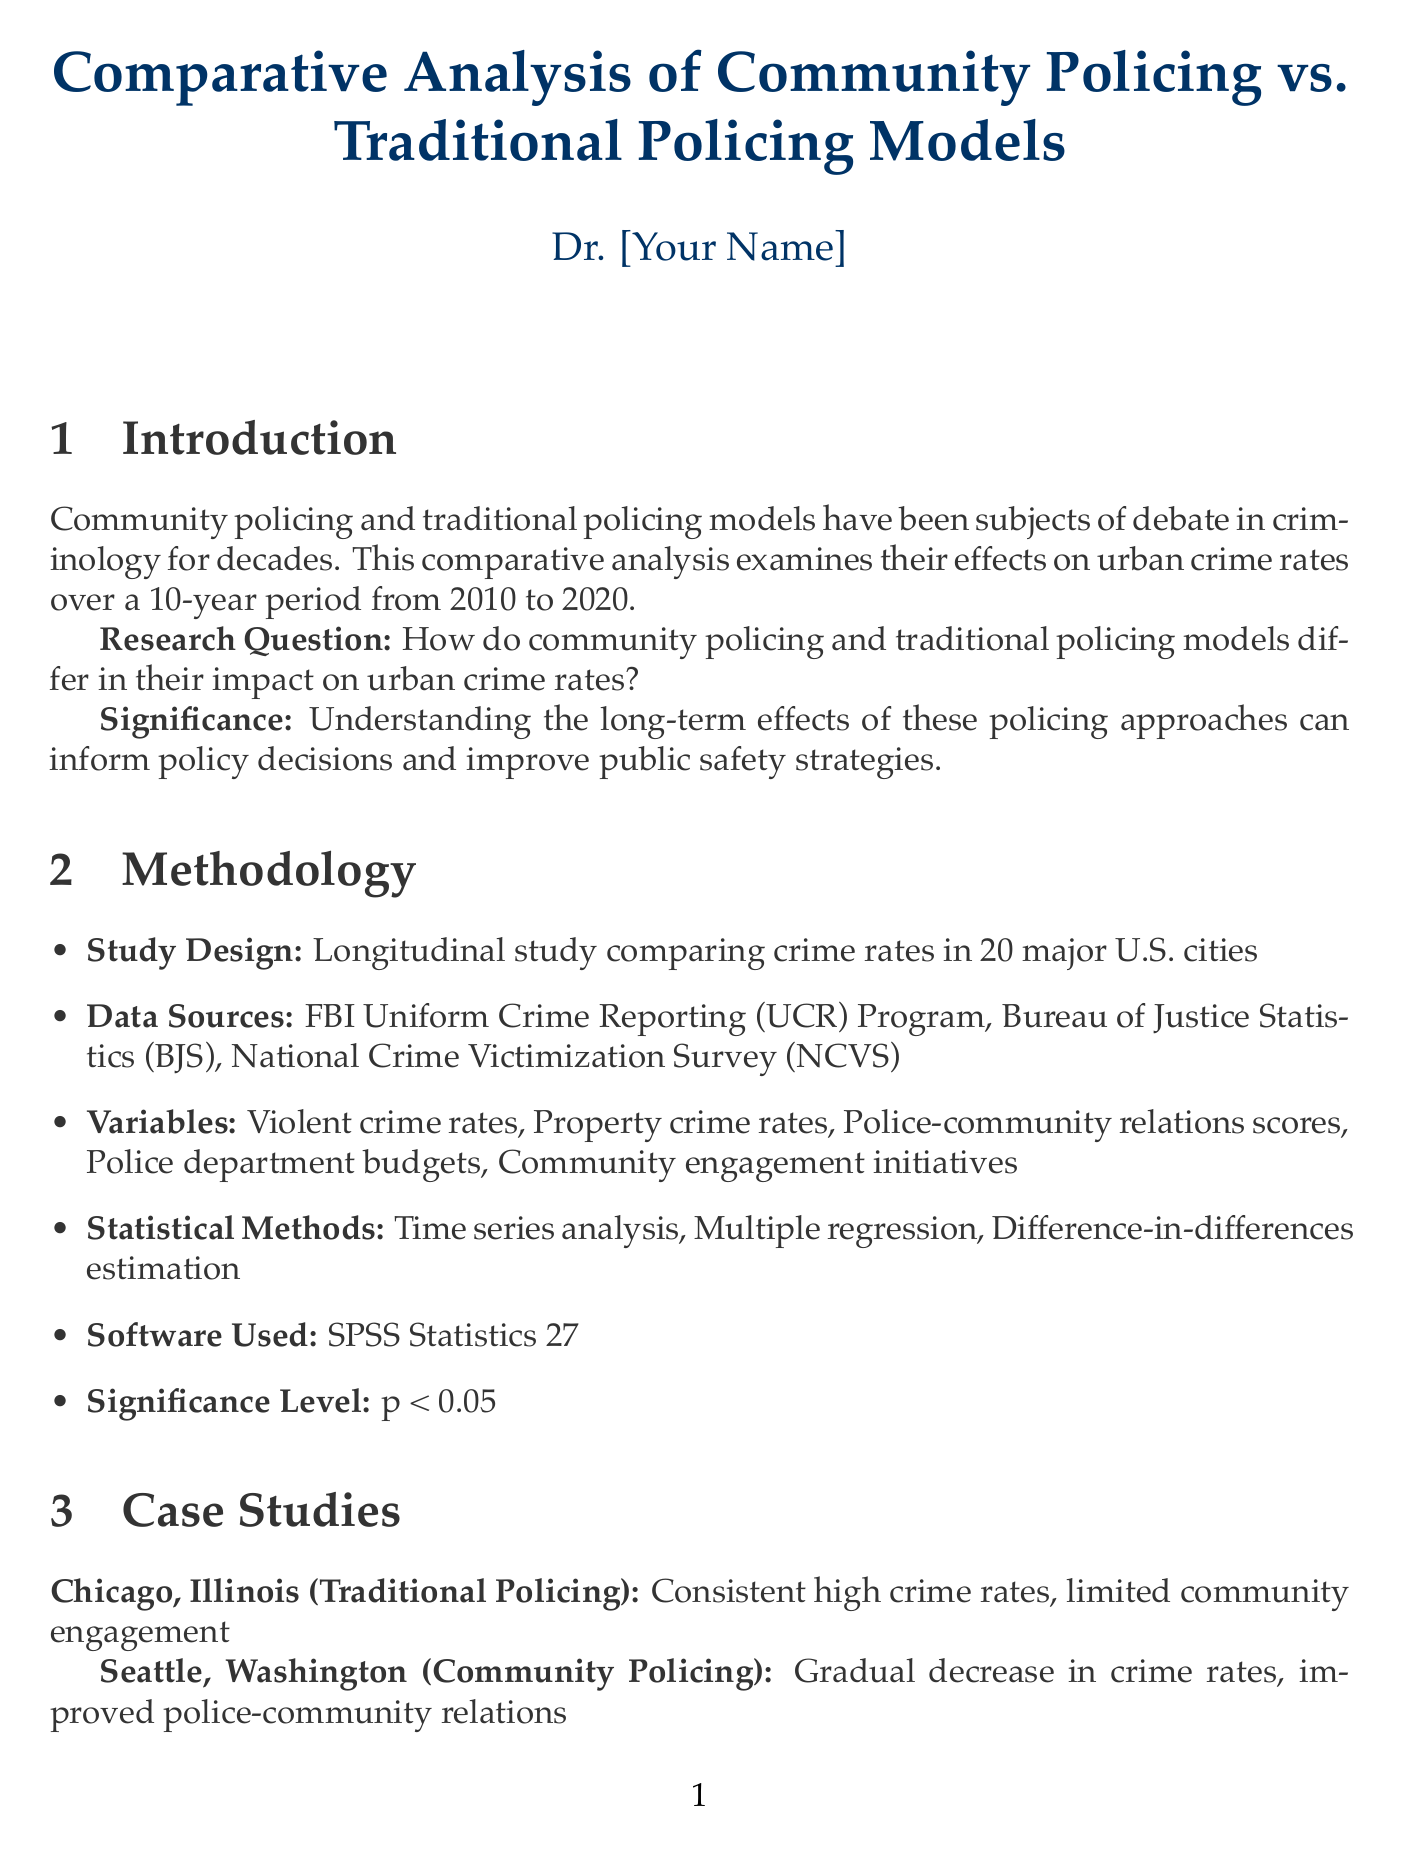What years does the analysis cover? The analysis examines urban crime rates over a 10-year period from 2010 to 2020.
Answer: 2010 to 2020 What statistical software was used in the study? The report specifies that SPSS Statistics 27 was used for data analysis.
Answer: SPSS Statistics 27 What is the percentage reduction in violent crime associated with community policing? The report indicates that community policing is associated with a 15% reduction in violent crime over 10 years.
Answer: 15% What was the key finding related to property crime and community policing? The document states that community policing was more effective in reducing property crime, specifically an 18% reduction.
Answer: 18% Which city showed a gradual decrease in crime rates? According to the case studies, Seattle, Washington showed a gradual decrease in crime rates.
Answer: Seattle, Washington What is a recommended policy implication for policing strategies? The recommendations include increasing funding for community engagement programs to enhance long-term crime reduction.
Answer: Increased funding for community engagement programs What is the significance of understanding policing effects on crime rates? The document states that understanding these effects can inform policy decisions and improve public safety strategies.
Answer: Inform policy decisions Who quoted about the need for genuine organizational change within police departments? Dr. Cynthia Lum, affiliated with the Center for Evidence-Based Crime Policy, is cited regarding this need.
Answer: Dr. Cynthia Lum 